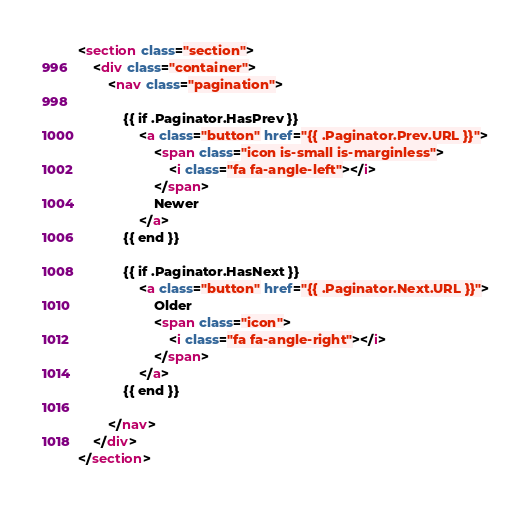<code> <loc_0><loc_0><loc_500><loc_500><_HTML_><section class="section">
    <div class="container">
        <nav class="pagination">

            {{ if .Paginator.HasPrev }}
                <a class="button" href="{{ .Paginator.Prev.URL }}">
                    <span class="icon is-small is-marginless">
                        <i class="fa fa-angle-left"></i>
                    </span>
                    Newer
                </a>
            {{ end }}

            {{ if .Paginator.HasNext }}
                <a class="button" href="{{ .Paginator.Next.URL }}">
                    Older
                    <span class="icon">
                        <i class="fa fa-angle-right"></i>
                    </span>
                </a>
            {{ end }}

        </nav>
    </div>
</section>
</code> 